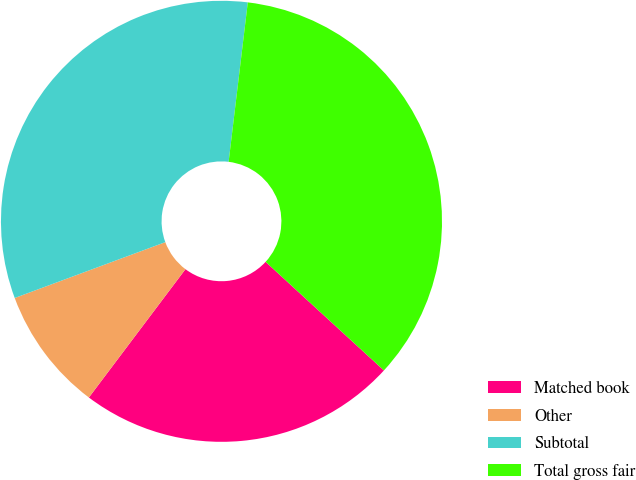Convert chart. <chart><loc_0><loc_0><loc_500><loc_500><pie_chart><fcel>Matched book<fcel>Other<fcel>Subtotal<fcel>Total gross fair<nl><fcel>23.45%<fcel>9.08%<fcel>32.56%<fcel>34.92%<nl></chart> 